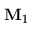<formula> <loc_0><loc_0><loc_500><loc_500>{ { M } _ { 1 } }</formula> 